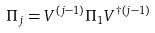<formula> <loc_0><loc_0><loc_500><loc_500>\Pi _ { j } = V ^ { ( j - 1 ) } \Pi _ { 1 } V ^ { \dag ( j - 1 ) }</formula> 